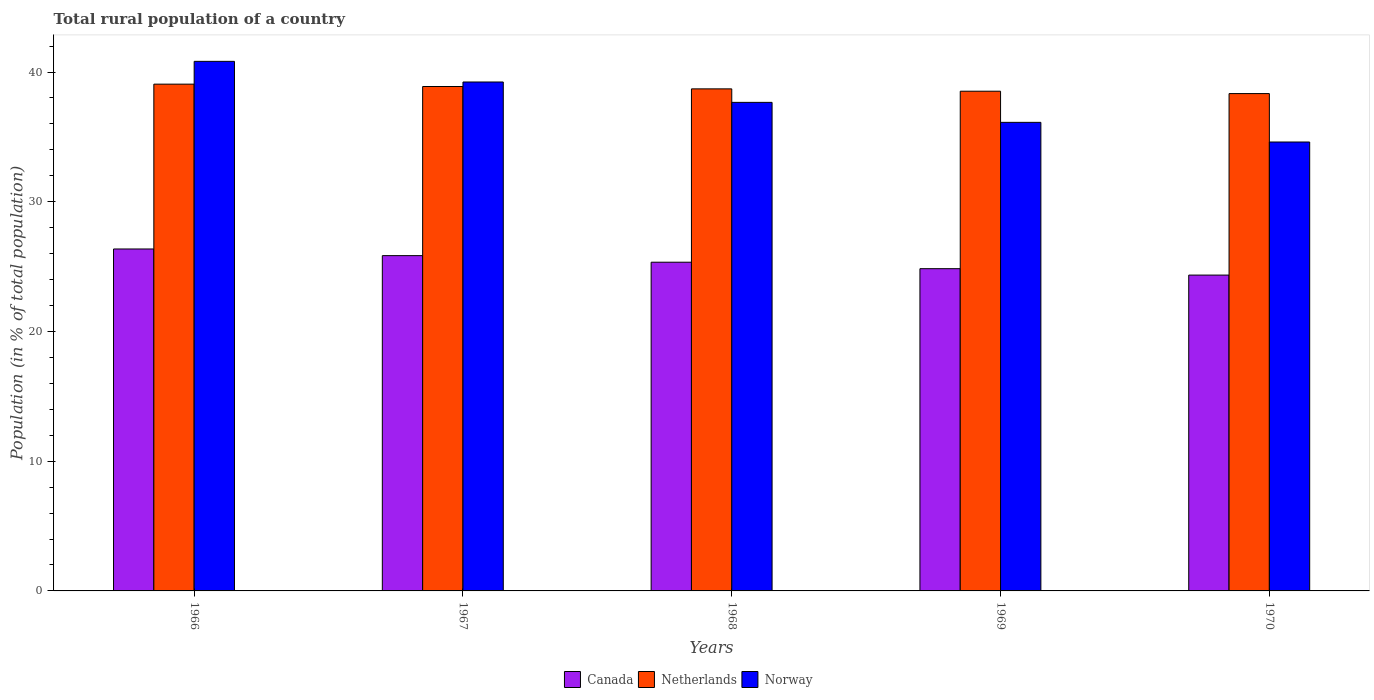How many different coloured bars are there?
Give a very brief answer. 3. What is the label of the 4th group of bars from the left?
Your answer should be compact. 1969. In how many cases, is the number of bars for a given year not equal to the number of legend labels?
Ensure brevity in your answer.  0. What is the rural population in Canada in 1966?
Provide a short and direct response. 26.36. Across all years, what is the maximum rural population in Netherlands?
Offer a very short reply. 39.06. Across all years, what is the minimum rural population in Norway?
Offer a very short reply. 34.6. In which year was the rural population in Canada maximum?
Give a very brief answer. 1966. In which year was the rural population in Canada minimum?
Your answer should be compact. 1970. What is the total rural population in Norway in the graph?
Ensure brevity in your answer.  188.43. What is the difference between the rural population in Norway in 1968 and that in 1969?
Your response must be concise. 1.54. What is the difference between the rural population in Canada in 1968 and the rural population in Netherlands in 1970?
Provide a succinct answer. -13. What is the average rural population in Canada per year?
Your answer should be very brief. 25.35. In the year 1966, what is the difference between the rural population in Netherlands and rural population in Norway?
Offer a terse response. -1.76. In how many years, is the rural population in Netherlands greater than 10 %?
Your response must be concise. 5. What is the ratio of the rural population in Canada in 1966 to that in 1967?
Keep it short and to the point. 1.02. Is the rural population in Norway in 1968 less than that in 1969?
Offer a terse response. No. What is the difference between the highest and the second highest rural population in Canada?
Offer a terse response. 0.51. What is the difference between the highest and the lowest rural population in Norway?
Your answer should be compact. 6.22. In how many years, is the rural population in Norway greater than the average rural population in Norway taken over all years?
Provide a succinct answer. 2. Is it the case that in every year, the sum of the rural population in Canada and rural population in Norway is greater than the rural population in Netherlands?
Provide a succinct answer. Yes. How many years are there in the graph?
Make the answer very short. 5. Are the values on the major ticks of Y-axis written in scientific E-notation?
Give a very brief answer. No. Does the graph contain grids?
Provide a short and direct response. No. How many legend labels are there?
Your answer should be very brief. 3. What is the title of the graph?
Offer a very short reply. Total rural population of a country. What is the label or title of the Y-axis?
Give a very brief answer. Population (in % of total population). What is the Population (in % of total population) of Canada in 1966?
Offer a terse response. 26.36. What is the Population (in % of total population) in Netherlands in 1966?
Your response must be concise. 39.06. What is the Population (in % of total population) in Norway in 1966?
Make the answer very short. 40.82. What is the Population (in % of total population) of Canada in 1967?
Your answer should be compact. 25.84. What is the Population (in % of total population) of Netherlands in 1967?
Make the answer very short. 38.88. What is the Population (in % of total population) in Norway in 1967?
Provide a succinct answer. 39.23. What is the Population (in % of total population) of Canada in 1968?
Offer a very short reply. 25.34. What is the Population (in % of total population) of Netherlands in 1968?
Offer a terse response. 38.7. What is the Population (in % of total population) of Norway in 1968?
Your response must be concise. 37.66. What is the Population (in % of total population) of Canada in 1969?
Make the answer very short. 24.84. What is the Population (in % of total population) of Netherlands in 1969?
Give a very brief answer. 38.52. What is the Population (in % of total population) in Norway in 1969?
Provide a succinct answer. 36.12. What is the Population (in % of total population) in Canada in 1970?
Your response must be concise. 24.35. What is the Population (in % of total population) in Netherlands in 1970?
Your answer should be very brief. 38.34. What is the Population (in % of total population) of Norway in 1970?
Give a very brief answer. 34.6. Across all years, what is the maximum Population (in % of total population) of Canada?
Provide a succinct answer. 26.36. Across all years, what is the maximum Population (in % of total population) of Netherlands?
Your answer should be very brief. 39.06. Across all years, what is the maximum Population (in % of total population) of Norway?
Offer a very short reply. 40.82. Across all years, what is the minimum Population (in % of total population) in Canada?
Keep it short and to the point. 24.35. Across all years, what is the minimum Population (in % of total population) in Netherlands?
Provide a succinct answer. 38.34. Across all years, what is the minimum Population (in % of total population) of Norway?
Make the answer very short. 34.6. What is the total Population (in % of total population) of Canada in the graph?
Provide a succinct answer. 126.73. What is the total Population (in % of total population) in Netherlands in the graph?
Provide a succinct answer. 193.5. What is the total Population (in % of total population) of Norway in the graph?
Offer a very short reply. 188.43. What is the difference between the Population (in % of total population) of Canada in 1966 and that in 1967?
Your answer should be very brief. 0.51. What is the difference between the Population (in % of total population) of Netherlands in 1966 and that in 1967?
Offer a terse response. 0.18. What is the difference between the Population (in % of total population) in Norway in 1966 and that in 1967?
Your answer should be very brief. 1.59. What is the difference between the Population (in % of total population) in Netherlands in 1966 and that in 1968?
Give a very brief answer. 0.36. What is the difference between the Population (in % of total population) in Norway in 1966 and that in 1968?
Ensure brevity in your answer.  3.16. What is the difference between the Population (in % of total population) of Canada in 1966 and that in 1969?
Give a very brief answer. 1.52. What is the difference between the Population (in % of total population) of Netherlands in 1966 and that in 1969?
Make the answer very short. 0.55. What is the difference between the Population (in % of total population) in Norway in 1966 and that in 1969?
Give a very brief answer. 4.7. What is the difference between the Population (in % of total population) of Canada in 1966 and that in 1970?
Offer a terse response. 2.01. What is the difference between the Population (in % of total population) of Netherlands in 1966 and that in 1970?
Offer a very short reply. 0.73. What is the difference between the Population (in % of total population) in Norway in 1966 and that in 1970?
Your response must be concise. 6.22. What is the difference between the Population (in % of total population) of Canada in 1967 and that in 1968?
Provide a short and direct response. 0.51. What is the difference between the Population (in % of total population) of Netherlands in 1967 and that in 1968?
Offer a very short reply. 0.18. What is the difference between the Population (in % of total population) in Norway in 1967 and that in 1968?
Keep it short and to the point. 1.57. What is the difference between the Population (in % of total population) in Canada in 1967 and that in 1969?
Ensure brevity in your answer.  1.01. What is the difference between the Population (in % of total population) of Netherlands in 1967 and that in 1969?
Ensure brevity in your answer.  0.36. What is the difference between the Population (in % of total population) of Norway in 1967 and that in 1969?
Offer a very short reply. 3.11. What is the difference between the Population (in % of total population) of Canada in 1967 and that in 1970?
Provide a short and direct response. 1.5. What is the difference between the Population (in % of total population) of Netherlands in 1967 and that in 1970?
Your answer should be very brief. 0.55. What is the difference between the Population (in % of total population) in Norway in 1967 and that in 1970?
Offer a very short reply. 4.63. What is the difference between the Population (in % of total population) in Canada in 1968 and that in 1969?
Your answer should be very brief. 0.5. What is the difference between the Population (in % of total population) in Netherlands in 1968 and that in 1969?
Your response must be concise. 0.18. What is the difference between the Population (in % of total population) of Norway in 1968 and that in 1969?
Offer a very short reply. 1.54. What is the difference between the Population (in % of total population) of Netherlands in 1968 and that in 1970?
Your response must be concise. 0.36. What is the difference between the Population (in % of total population) of Norway in 1968 and that in 1970?
Your answer should be very brief. 3.06. What is the difference between the Population (in % of total population) in Canada in 1969 and that in 1970?
Your response must be concise. 0.49. What is the difference between the Population (in % of total population) of Netherlands in 1969 and that in 1970?
Offer a very short reply. 0.18. What is the difference between the Population (in % of total population) in Norway in 1969 and that in 1970?
Your answer should be compact. 1.51. What is the difference between the Population (in % of total population) in Canada in 1966 and the Population (in % of total population) in Netherlands in 1967?
Provide a succinct answer. -12.52. What is the difference between the Population (in % of total population) in Canada in 1966 and the Population (in % of total population) in Norway in 1967?
Make the answer very short. -12.87. What is the difference between the Population (in % of total population) in Netherlands in 1966 and the Population (in % of total population) in Norway in 1967?
Your answer should be very brief. -0.17. What is the difference between the Population (in % of total population) of Canada in 1966 and the Population (in % of total population) of Netherlands in 1968?
Your answer should be compact. -12.34. What is the difference between the Population (in % of total population) in Canada in 1966 and the Population (in % of total population) in Norway in 1968?
Provide a short and direct response. -11.3. What is the difference between the Population (in % of total population) of Netherlands in 1966 and the Population (in % of total population) of Norway in 1968?
Ensure brevity in your answer.  1.4. What is the difference between the Population (in % of total population) in Canada in 1966 and the Population (in % of total population) in Netherlands in 1969?
Offer a terse response. -12.16. What is the difference between the Population (in % of total population) of Canada in 1966 and the Population (in % of total population) of Norway in 1969?
Provide a succinct answer. -9.76. What is the difference between the Population (in % of total population) in Netherlands in 1966 and the Population (in % of total population) in Norway in 1969?
Your response must be concise. 2.94. What is the difference between the Population (in % of total population) of Canada in 1966 and the Population (in % of total population) of Netherlands in 1970?
Provide a succinct answer. -11.98. What is the difference between the Population (in % of total population) of Canada in 1966 and the Population (in % of total population) of Norway in 1970?
Provide a succinct answer. -8.25. What is the difference between the Population (in % of total population) of Netherlands in 1966 and the Population (in % of total population) of Norway in 1970?
Make the answer very short. 4.46. What is the difference between the Population (in % of total population) of Canada in 1967 and the Population (in % of total population) of Netherlands in 1968?
Your answer should be very brief. -12.86. What is the difference between the Population (in % of total population) of Canada in 1967 and the Population (in % of total population) of Norway in 1968?
Your answer should be compact. -11.81. What is the difference between the Population (in % of total population) in Netherlands in 1967 and the Population (in % of total population) in Norway in 1968?
Your response must be concise. 1.22. What is the difference between the Population (in % of total population) in Canada in 1967 and the Population (in % of total population) in Netherlands in 1969?
Your answer should be compact. -12.67. What is the difference between the Population (in % of total population) in Canada in 1967 and the Population (in % of total population) in Norway in 1969?
Your answer should be compact. -10.27. What is the difference between the Population (in % of total population) of Netherlands in 1967 and the Population (in % of total population) of Norway in 1969?
Offer a very short reply. 2.76. What is the difference between the Population (in % of total population) in Canada in 1967 and the Population (in % of total population) in Netherlands in 1970?
Keep it short and to the point. -12.49. What is the difference between the Population (in % of total population) in Canada in 1967 and the Population (in % of total population) in Norway in 1970?
Give a very brief answer. -8.76. What is the difference between the Population (in % of total population) of Netherlands in 1967 and the Population (in % of total population) of Norway in 1970?
Provide a succinct answer. 4.28. What is the difference between the Population (in % of total population) of Canada in 1968 and the Population (in % of total population) of Netherlands in 1969?
Offer a terse response. -13.18. What is the difference between the Population (in % of total population) of Canada in 1968 and the Population (in % of total population) of Norway in 1969?
Your answer should be compact. -10.78. What is the difference between the Population (in % of total population) in Netherlands in 1968 and the Population (in % of total population) in Norway in 1969?
Your answer should be compact. 2.58. What is the difference between the Population (in % of total population) of Canada in 1968 and the Population (in % of total population) of Netherlands in 1970?
Your response must be concise. -13. What is the difference between the Population (in % of total population) of Canada in 1968 and the Population (in % of total population) of Norway in 1970?
Provide a succinct answer. -9.27. What is the difference between the Population (in % of total population) in Netherlands in 1968 and the Population (in % of total population) in Norway in 1970?
Provide a short and direct response. 4.1. What is the difference between the Population (in % of total population) in Canada in 1969 and the Population (in % of total population) in Netherlands in 1970?
Ensure brevity in your answer.  -13.5. What is the difference between the Population (in % of total population) in Canada in 1969 and the Population (in % of total population) in Norway in 1970?
Offer a very short reply. -9.77. What is the difference between the Population (in % of total population) of Netherlands in 1969 and the Population (in % of total population) of Norway in 1970?
Give a very brief answer. 3.92. What is the average Population (in % of total population) of Canada per year?
Make the answer very short. 25.35. What is the average Population (in % of total population) of Netherlands per year?
Offer a very short reply. 38.7. What is the average Population (in % of total population) of Norway per year?
Provide a short and direct response. 37.69. In the year 1966, what is the difference between the Population (in % of total population) in Canada and Population (in % of total population) in Netherlands?
Make the answer very short. -12.71. In the year 1966, what is the difference between the Population (in % of total population) in Canada and Population (in % of total population) in Norway?
Give a very brief answer. -14.46. In the year 1966, what is the difference between the Population (in % of total population) in Netherlands and Population (in % of total population) in Norway?
Offer a very short reply. -1.76. In the year 1967, what is the difference between the Population (in % of total population) in Canada and Population (in % of total population) in Netherlands?
Offer a very short reply. -13.04. In the year 1967, what is the difference between the Population (in % of total population) of Canada and Population (in % of total population) of Norway?
Ensure brevity in your answer.  -13.38. In the year 1967, what is the difference between the Population (in % of total population) in Netherlands and Population (in % of total population) in Norway?
Offer a very short reply. -0.35. In the year 1968, what is the difference between the Population (in % of total population) of Canada and Population (in % of total population) of Netherlands?
Offer a terse response. -13.36. In the year 1968, what is the difference between the Population (in % of total population) in Canada and Population (in % of total population) in Norway?
Provide a short and direct response. -12.32. In the year 1969, what is the difference between the Population (in % of total population) in Canada and Population (in % of total population) in Netherlands?
Your response must be concise. -13.68. In the year 1969, what is the difference between the Population (in % of total population) in Canada and Population (in % of total population) in Norway?
Offer a terse response. -11.28. In the year 1970, what is the difference between the Population (in % of total population) in Canada and Population (in % of total population) in Netherlands?
Offer a very short reply. -13.99. In the year 1970, what is the difference between the Population (in % of total population) of Canada and Population (in % of total population) of Norway?
Make the answer very short. -10.26. In the year 1970, what is the difference between the Population (in % of total population) of Netherlands and Population (in % of total population) of Norway?
Your response must be concise. 3.73. What is the ratio of the Population (in % of total population) in Canada in 1966 to that in 1967?
Give a very brief answer. 1.02. What is the ratio of the Population (in % of total population) in Netherlands in 1966 to that in 1967?
Your response must be concise. 1. What is the ratio of the Population (in % of total population) in Norway in 1966 to that in 1967?
Your answer should be compact. 1.04. What is the ratio of the Population (in % of total population) in Canada in 1966 to that in 1968?
Keep it short and to the point. 1.04. What is the ratio of the Population (in % of total population) of Netherlands in 1966 to that in 1968?
Give a very brief answer. 1.01. What is the ratio of the Population (in % of total population) of Norway in 1966 to that in 1968?
Your answer should be compact. 1.08. What is the ratio of the Population (in % of total population) of Canada in 1966 to that in 1969?
Offer a very short reply. 1.06. What is the ratio of the Population (in % of total population) in Netherlands in 1966 to that in 1969?
Provide a succinct answer. 1.01. What is the ratio of the Population (in % of total population) of Norway in 1966 to that in 1969?
Ensure brevity in your answer.  1.13. What is the ratio of the Population (in % of total population) of Canada in 1966 to that in 1970?
Your answer should be compact. 1.08. What is the ratio of the Population (in % of total population) in Norway in 1966 to that in 1970?
Keep it short and to the point. 1.18. What is the ratio of the Population (in % of total population) in Canada in 1967 to that in 1968?
Offer a very short reply. 1.02. What is the ratio of the Population (in % of total population) in Netherlands in 1967 to that in 1968?
Ensure brevity in your answer.  1. What is the ratio of the Population (in % of total population) in Norway in 1967 to that in 1968?
Ensure brevity in your answer.  1.04. What is the ratio of the Population (in % of total population) of Canada in 1967 to that in 1969?
Offer a terse response. 1.04. What is the ratio of the Population (in % of total population) of Netherlands in 1967 to that in 1969?
Your answer should be compact. 1.01. What is the ratio of the Population (in % of total population) of Norway in 1967 to that in 1969?
Keep it short and to the point. 1.09. What is the ratio of the Population (in % of total population) in Canada in 1967 to that in 1970?
Keep it short and to the point. 1.06. What is the ratio of the Population (in % of total population) in Netherlands in 1967 to that in 1970?
Offer a terse response. 1.01. What is the ratio of the Population (in % of total population) in Norway in 1967 to that in 1970?
Your response must be concise. 1.13. What is the ratio of the Population (in % of total population) of Canada in 1968 to that in 1969?
Your response must be concise. 1.02. What is the ratio of the Population (in % of total population) in Norway in 1968 to that in 1969?
Offer a terse response. 1.04. What is the ratio of the Population (in % of total population) of Canada in 1968 to that in 1970?
Your response must be concise. 1.04. What is the ratio of the Population (in % of total population) of Netherlands in 1968 to that in 1970?
Ensure brevity in your answer.  1.01. What is the ratio of the Population (in % of total population) in Norway in 1968 to that in 1970?
Provide a short and direct response. 1.09. What is the ratio of the Population (in % of total population) in Canada in 1969 to that in 1970?
Ensure brevity in your answer.  1.02. What is the ratio of the Population (in % of total population) of Norway in 1969 to that in 1970?
Give a very brief answer. 1.04. What is the difference between the highest and the second highest Population (in % of total population) in Canada?
Make the answer very short. 0.51. What is the difference between the highest and the second highest Population (in % of total population) in Netherlands?
Keep it short and to the point. 0.18. What is the difference between the highest and the second highest Population (in % of total population) in Norway?
Ensure brevity in your answer.  1.59. What is the difference between the highest and the lowest Population (in % of total population) of Canada?
Offer a very short reply. 2.01. What is the difference between the highest and the lowest Population (in % of total population) in Netherlands?
Provide a short and direct response. 0.73. What is the difference between the highest and the lowest Population (in % of total population) of Norway?
Offer a very short reply. 6.22. 